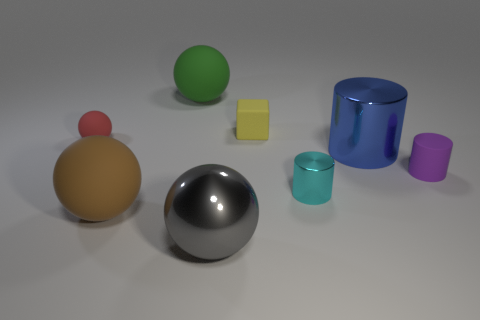How many rubber spheres are on the right side of the small ball and behind the big cylinder?
Ensure brevity in your answer.  1. What is the color of the big rubber sphere behind the small purple cylinder?
Provide a succinct answer. Green. What size is the ball that is the same material as the cyan cylinder?
Give a very brief answer. Large. There is a large sphere that is left of the green thing; what number of big cylinders are to the left of it?
Your response must be concise. 0. What number of big green matte objects are behind the small purple matte thing?
Make the answer very short. 1. The sphere behind the tiny matte thing on the left side of the large matte object behind the red matte sphere is what color?
Give a very brief answer. Green. There is a object that is in front of the brown rubber object; is it the same color as the small matte thing that is behind the red matte sphere?
Offer a terse response. No. What shape is the big rubber thing right of the big rubber thing in front of the green matte sphere?
Your response must be concise. Sphere. Are there any gray matte cylinders of the same size as the gray sphere?
Provide a succinct answer. No. What number of other large gray metallic things have the same shape as the big gray metal thing?
Keep it short and to the point. 0. 